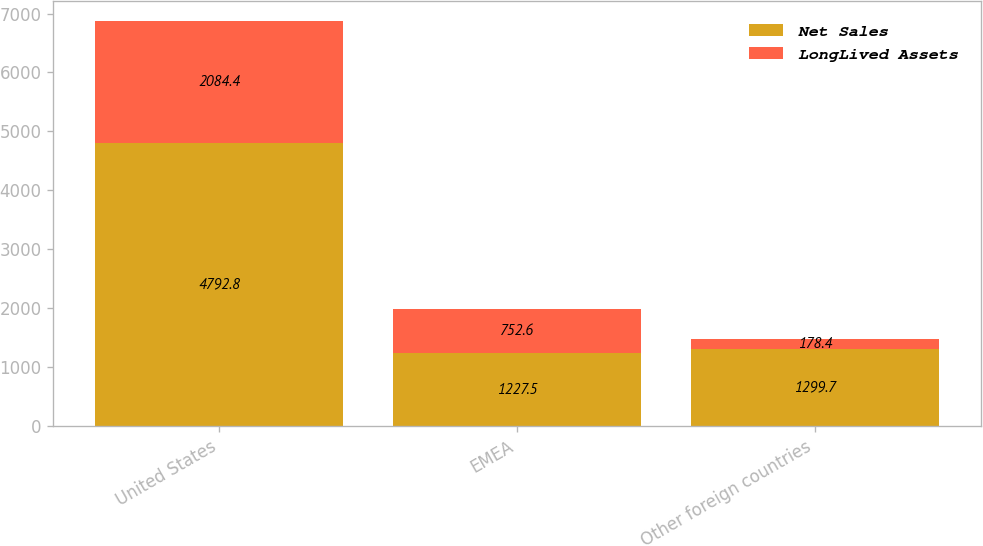Convert chart to OTSL. <chart><loc_0><loc_0><loc_500><loc_500><stacked_bar_chart><ecel><fcel>United States<fcel>EMEA<fcel>Other foreign countries<nl><fcel>Net Sales<fcel>4792.8<fcel>1227.5<fcel>1299.7<nl><fcel>LongLived Assets<fcel>2084.4<fcel>752.6<fcel>178.4<nl></chart> 